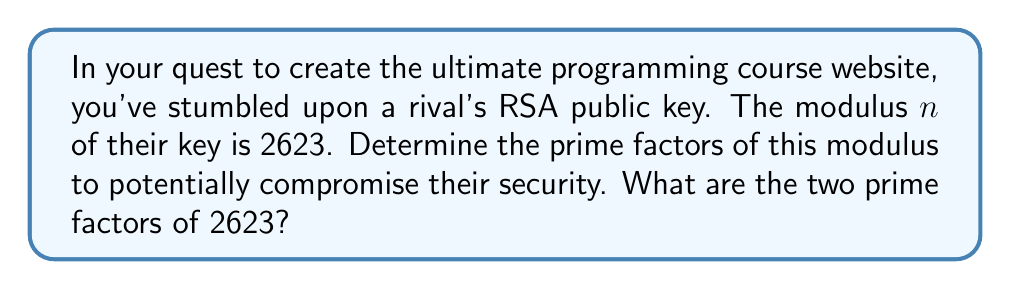Give your solution to this math problem. To find the prime factors of 2623, we'll use the trial division method:

1) First, let's check if 2623 is divisible by small prime numbers:
   $2623 \not\equiv 0 \pmod{2}$
   $2623 \not\equiv 0 \pmod{3}$
   $2623 \not\equiv 0 \pmod{5}$
   $2623 \not\equiv 0 \pmod{7}$

2) We only need to check up to $\sqrt{2623} \approx 51.2$, so let's continue with prime numbers up to 51:
   $2623 \not\equiv 0 \pmod{11}$
   $2623 \not\equiv 0 \pmod{13}$
   $2623 \not\equiv 0 \pmod{17}$
   $2623 \not\equiv 0 \pmod{19}$
   $2623 \not\equiv 0 \pmod{23}$
   $2623 \not\equiv 0 \pmod{29}$
   $2623 \not\equiv 0 \pmod{31}$
   $2623 \not\equiv 0 \pmod{37}$
   $2623 \not\equiv 0 \pmod{41}$
   $2623 \equiv 0 \pmod{43}$

3) We've found that 43 divides 2623. Let's perform the division:
   $2623 \div 43 = 61$

4) Check if 61 is prime:
   $61 \not\equiv 0 \pmod{2}$
   $61 \not\equiv 0 \pmod{3}$
   $61 \not\equiv 0 \pmod{5}$
   $61 \not\equiv 0 \pmod{7}$
   $\sqrt{61} \approx 7.8$, so we don't need to check further.

5) Therefore, 61 is prime.

We've factored 2623 into two prime numbers: 43 and 61.
Answer: 43, 61 